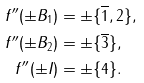<formula> <loc_0><loc_0><loc_500><loc_500>f ^ { \prime \prime } ( \pm B _ { 1 } ) & = \pm \{ \overline { 1 } , 2 \} , \\ f ^ { \prime \prime } ( \pm B _ { 2 } ) & = \pm \{ \overline { 3 } \} , \\ f ^ { \prime \prime } ( \pm I ) & = \pm \{ 4 \} .</formula> 